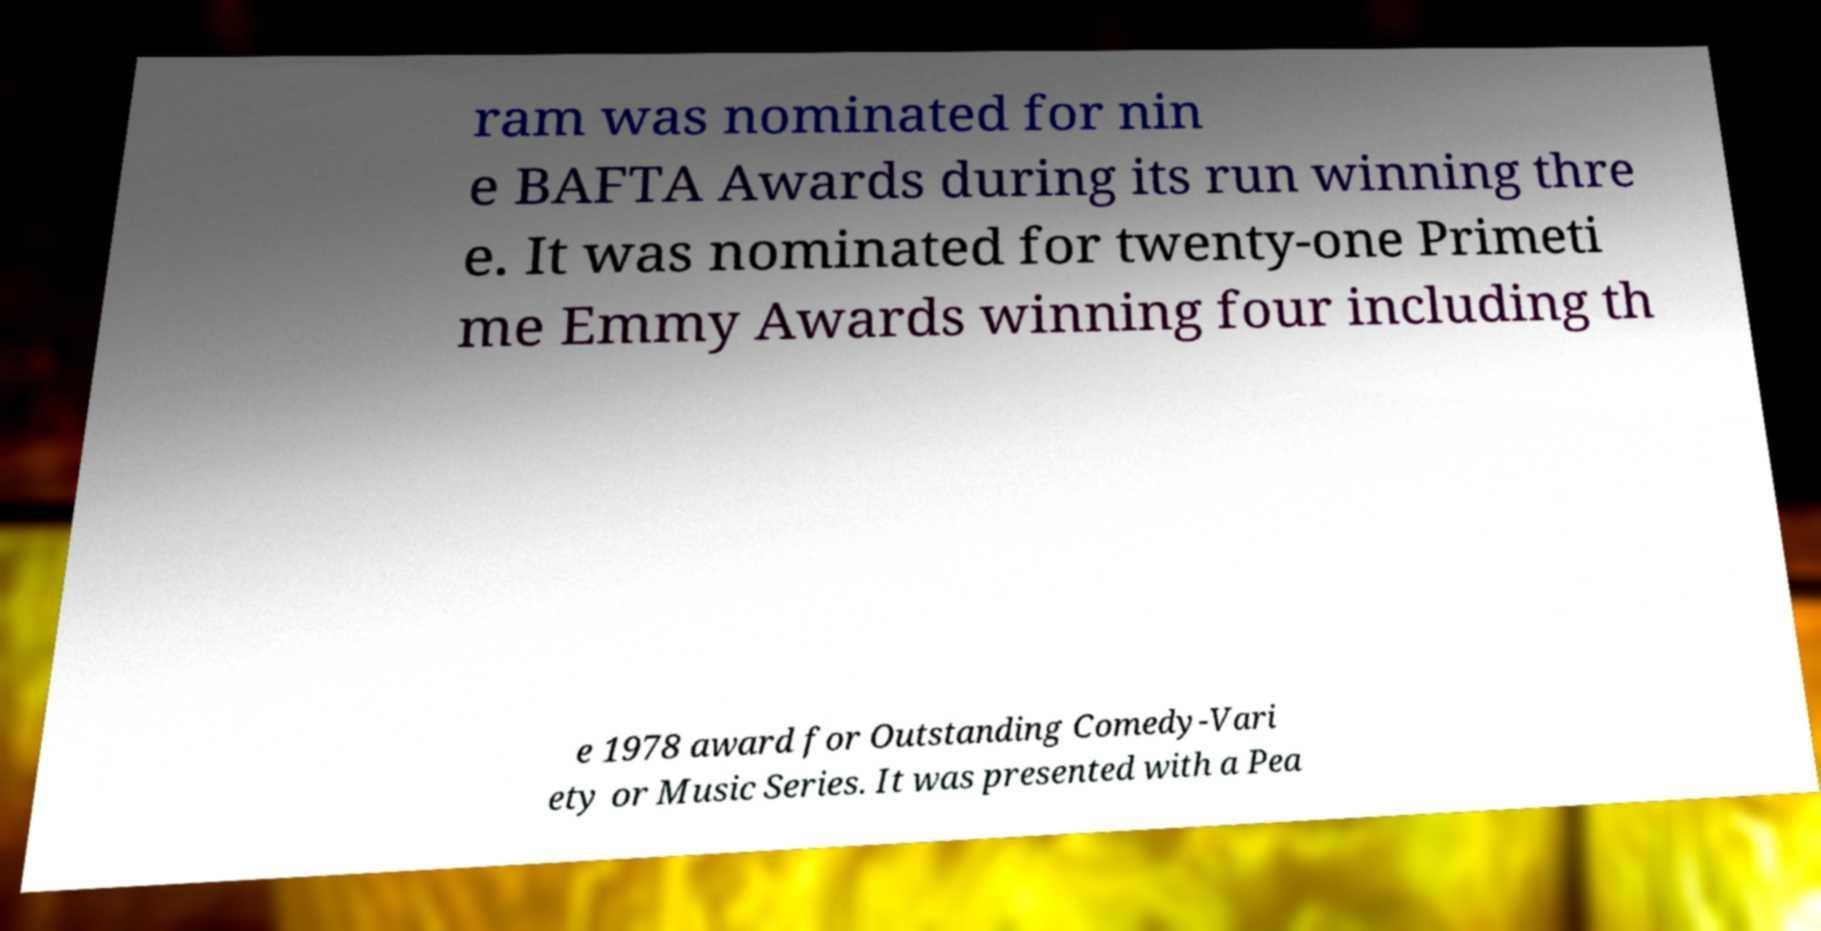For documentation purposes, I need the text within this image transcribed. Could you provide that? ram was nominated for nin e BAFTA Awards during its run winning thre e. It was nominated for twenty-one Primeti me Emmy Awards winning four including th e 1978 award for Outstanding Comedy-Vari ety or Music Series. It was presented with a Pea 